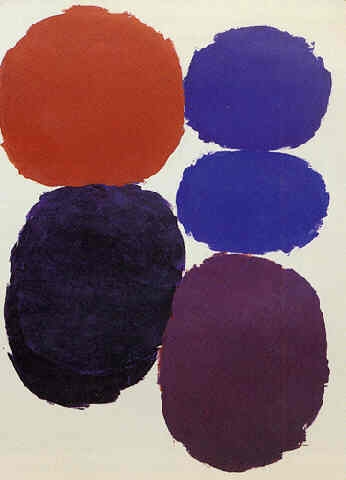How can the choice of colors in this artwork affect the viewer's emotional response? The selection of colors in this abstract piece can evoke a variety of emotions. The grounding red at the bottom may instill feelings of intensity or passion, while the cooler tones of blue and purple above might bring a sense of calmness or contemplation. The orange circle at the top could add a spark of energy or optimism, making the emotional journey of this artwork complex and layered. 